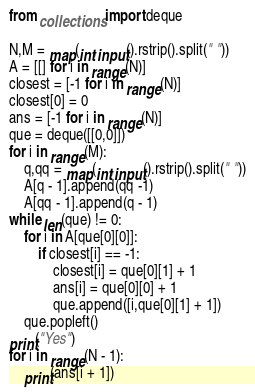<code> <loc_0><loc_0><loc_500><loc_500><_Python_>from collections import deque

N,M = map(int,input().rstrip().split(" "))
A = [[] for i in range(N)]
closest = [-1 for i in range(N)]
closest[0] = 0
ans = [-1 for i in range(N)]
que = deque([[0,0]])
for i in range(M):
    q,qq = map(int,input().rstrip().split(" "))
    A[q - 1].append(qq -1)
    A[qq - 1].append(q - 1)
while len(que) != 0:
    for i in A[que[0][0]]:
        if closest[i] == -1:
            closest[i] = que[0][1] + 1
            ans[i] = que[0][0] + 1
            que.append([i,que[0][1] + 1])
    que.popleft()
print("Yes")
for i in range(N - 1):
    print(ans[i + 1])</code> 